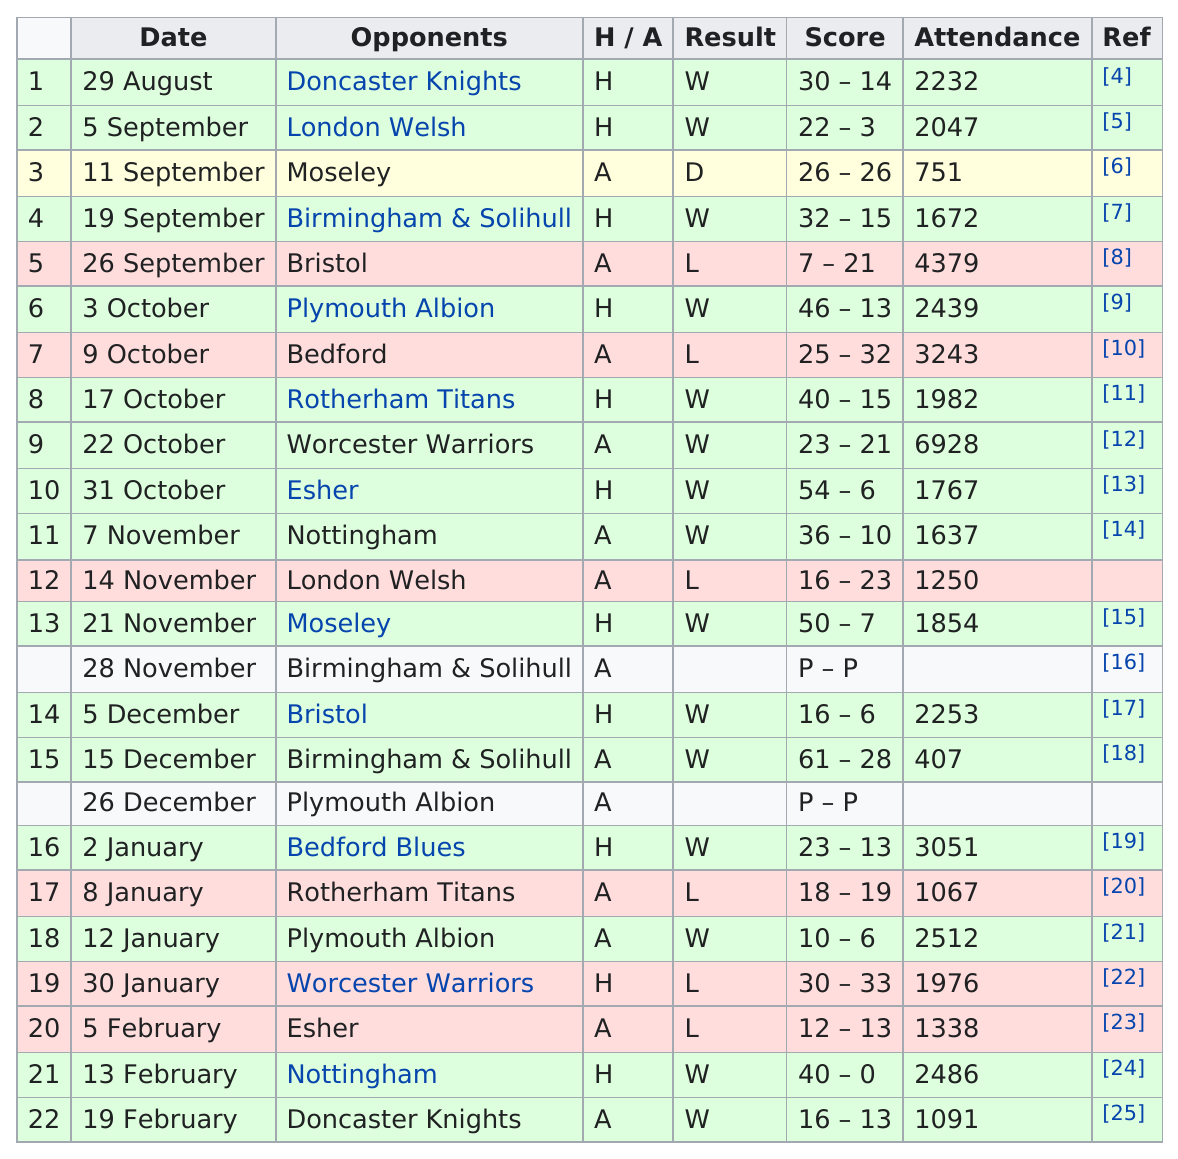Give some essential details in this illustration. Approximately 16 games were attended by more than 1500 people. As of this season, the number of games played in October is 5. On November 14, the team suffered a loss. The date of their previous loss was October 9. The last game that was attended by more than 2000 people was on 13 February. The match with a larger attendance was between 1 and 12, as it had 12 as a value, while 1 had a different value. 